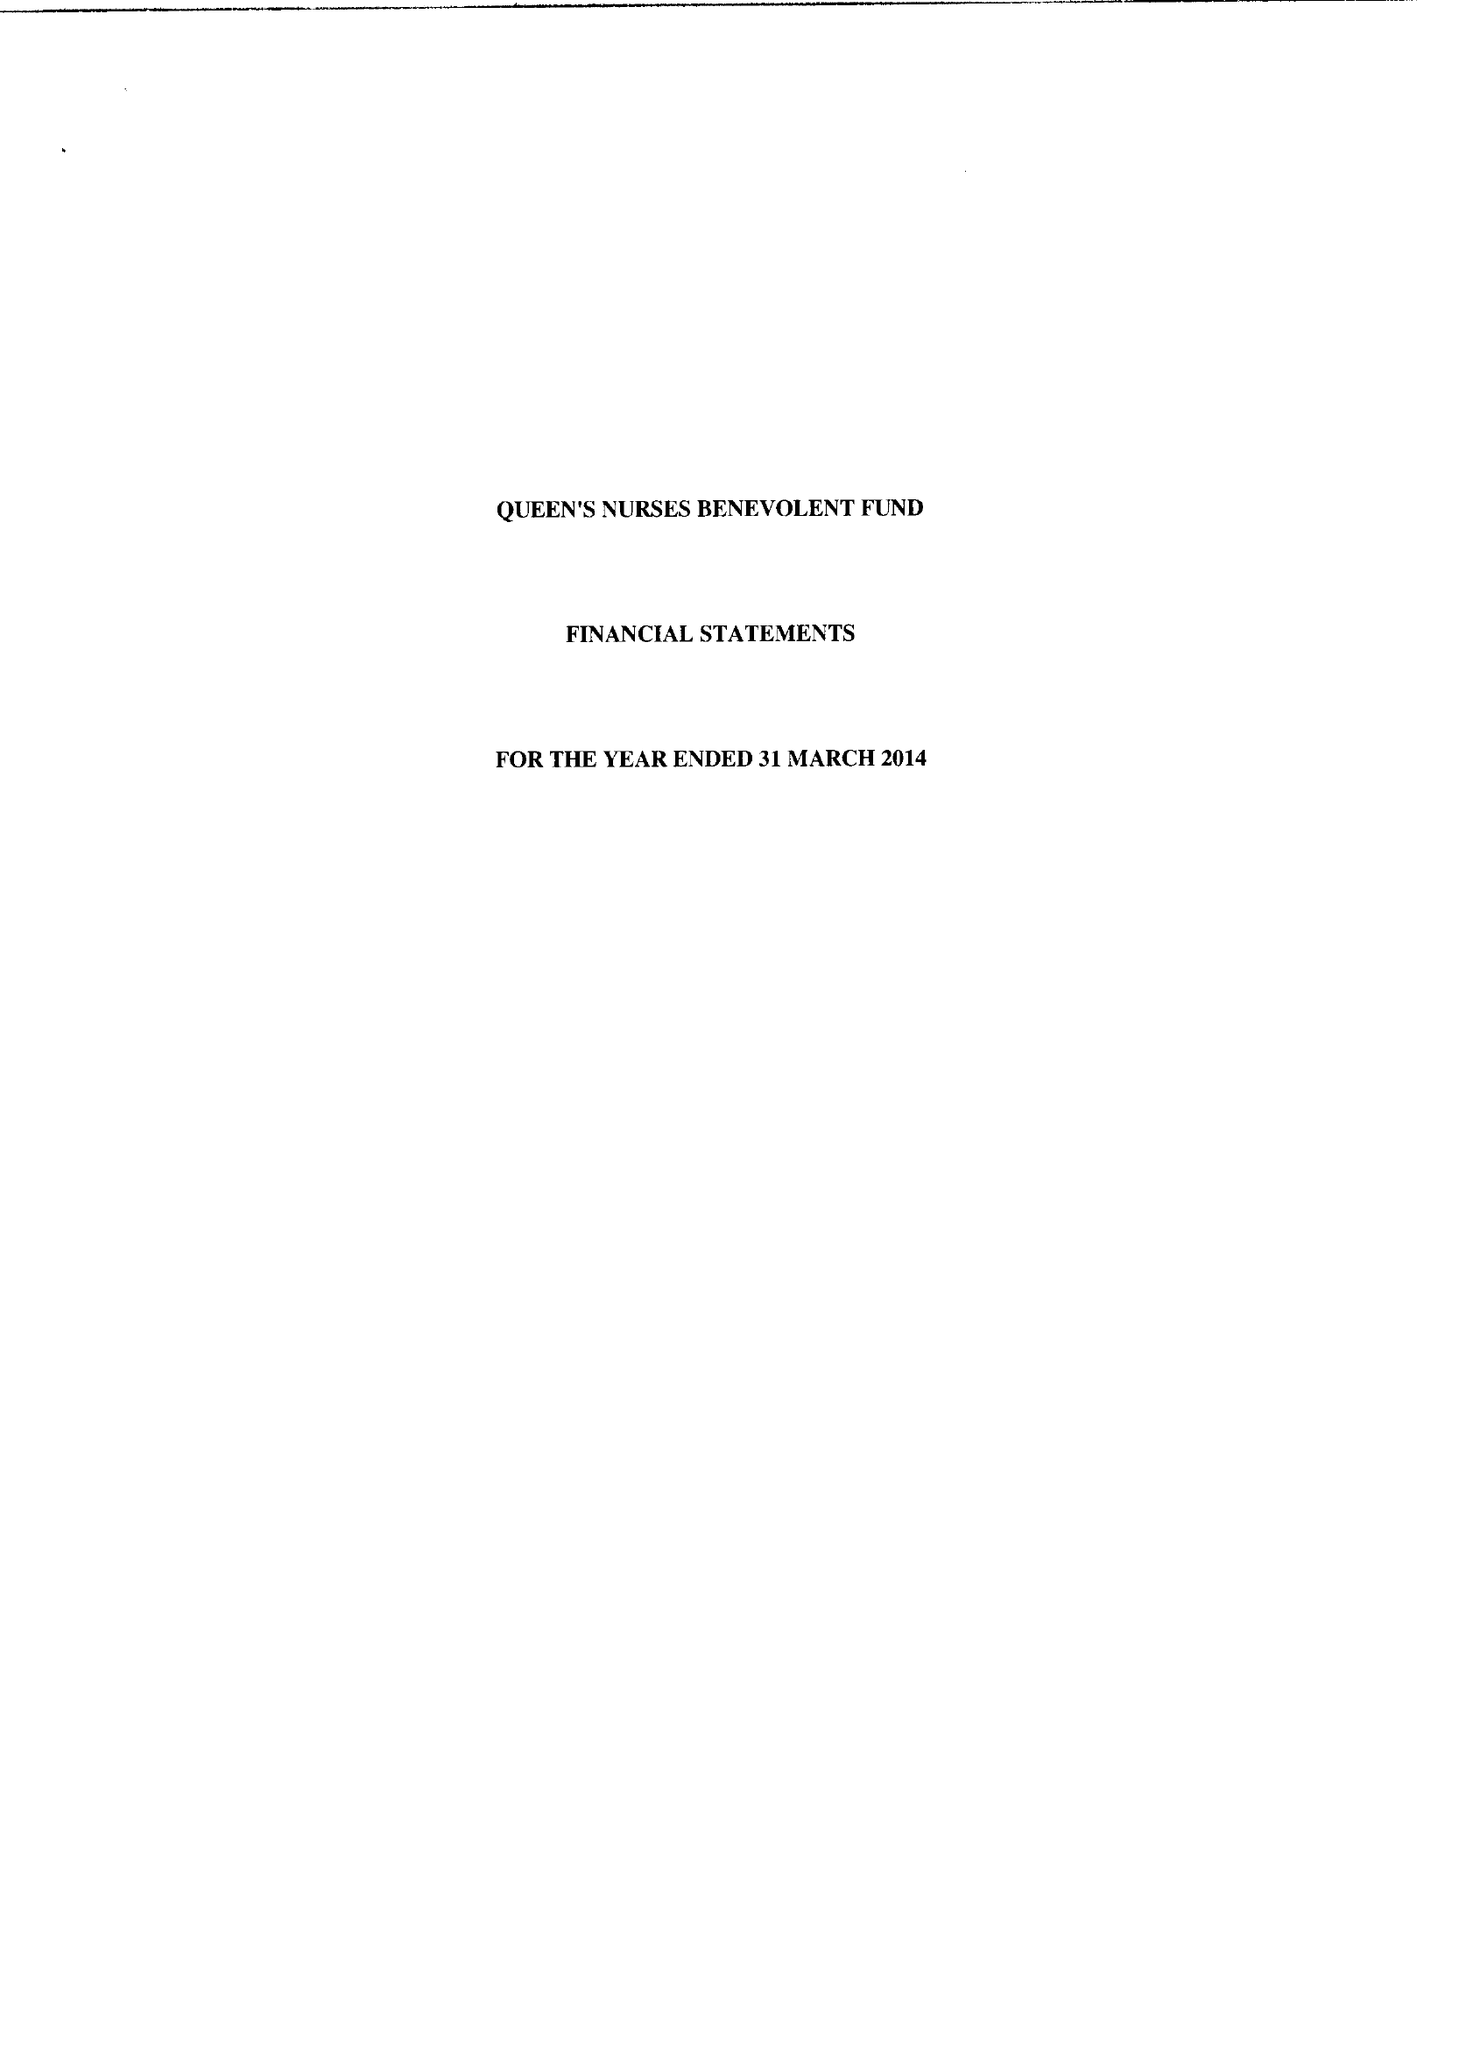What is the value for the address__street_line?
Answer the question using a single word or phrase. 76 QUARRY PARK ROAD 